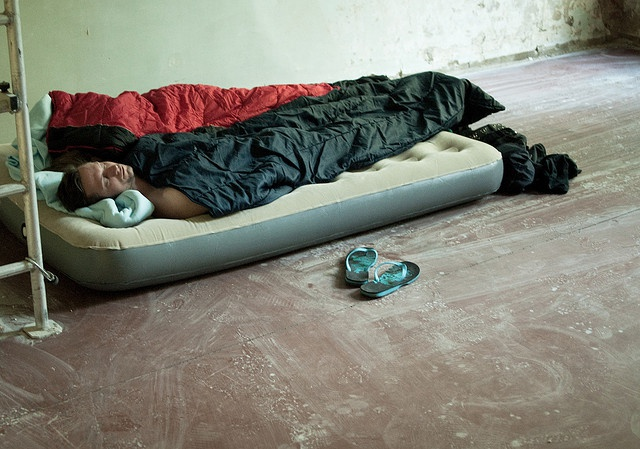Describe the objects in this image and their specific colors. I can see people in olive, black, teal, and maroon tones and bed in olive, gray, black, beige, and darkgray tones in this image. 